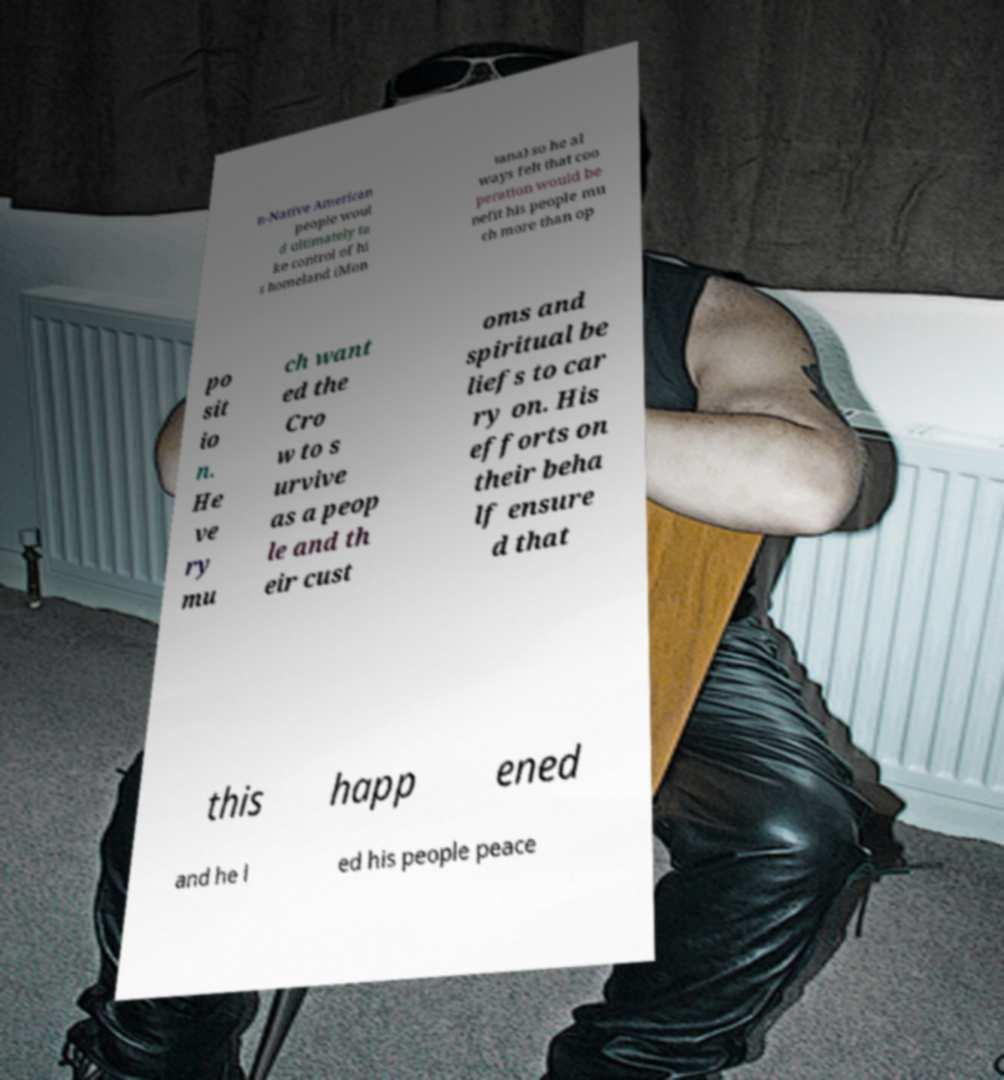Please read and relay the text visible in this image. What does it say? n-Native American people woul d ultimately ta ke control of hi s homeland (Mon tana) so he al ways felt that coo peration would be nefit his people mu ch more than op po sit io n. He ve ry mu ch want ed the Cro w to s urvive as a peop le and th eir cust oms and spiritual be liefs to car ry on. His efforts on their beha lf ensure d that this happ ened and he l ed his people peace 